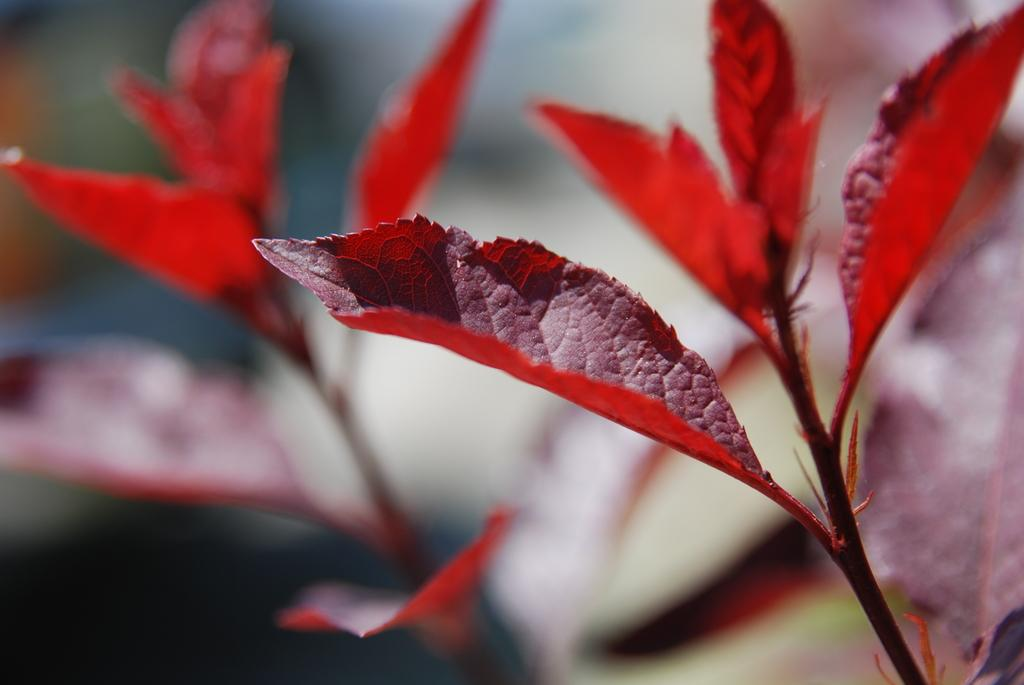What type of vegetation can be seen in the image? There are leaves in the image. Can you describe the background of the image? The background of the image is blurred. What hobbies does the beetle in the image enjoy? There is no beetle present in the image, so we cannot determine its hobbies. 